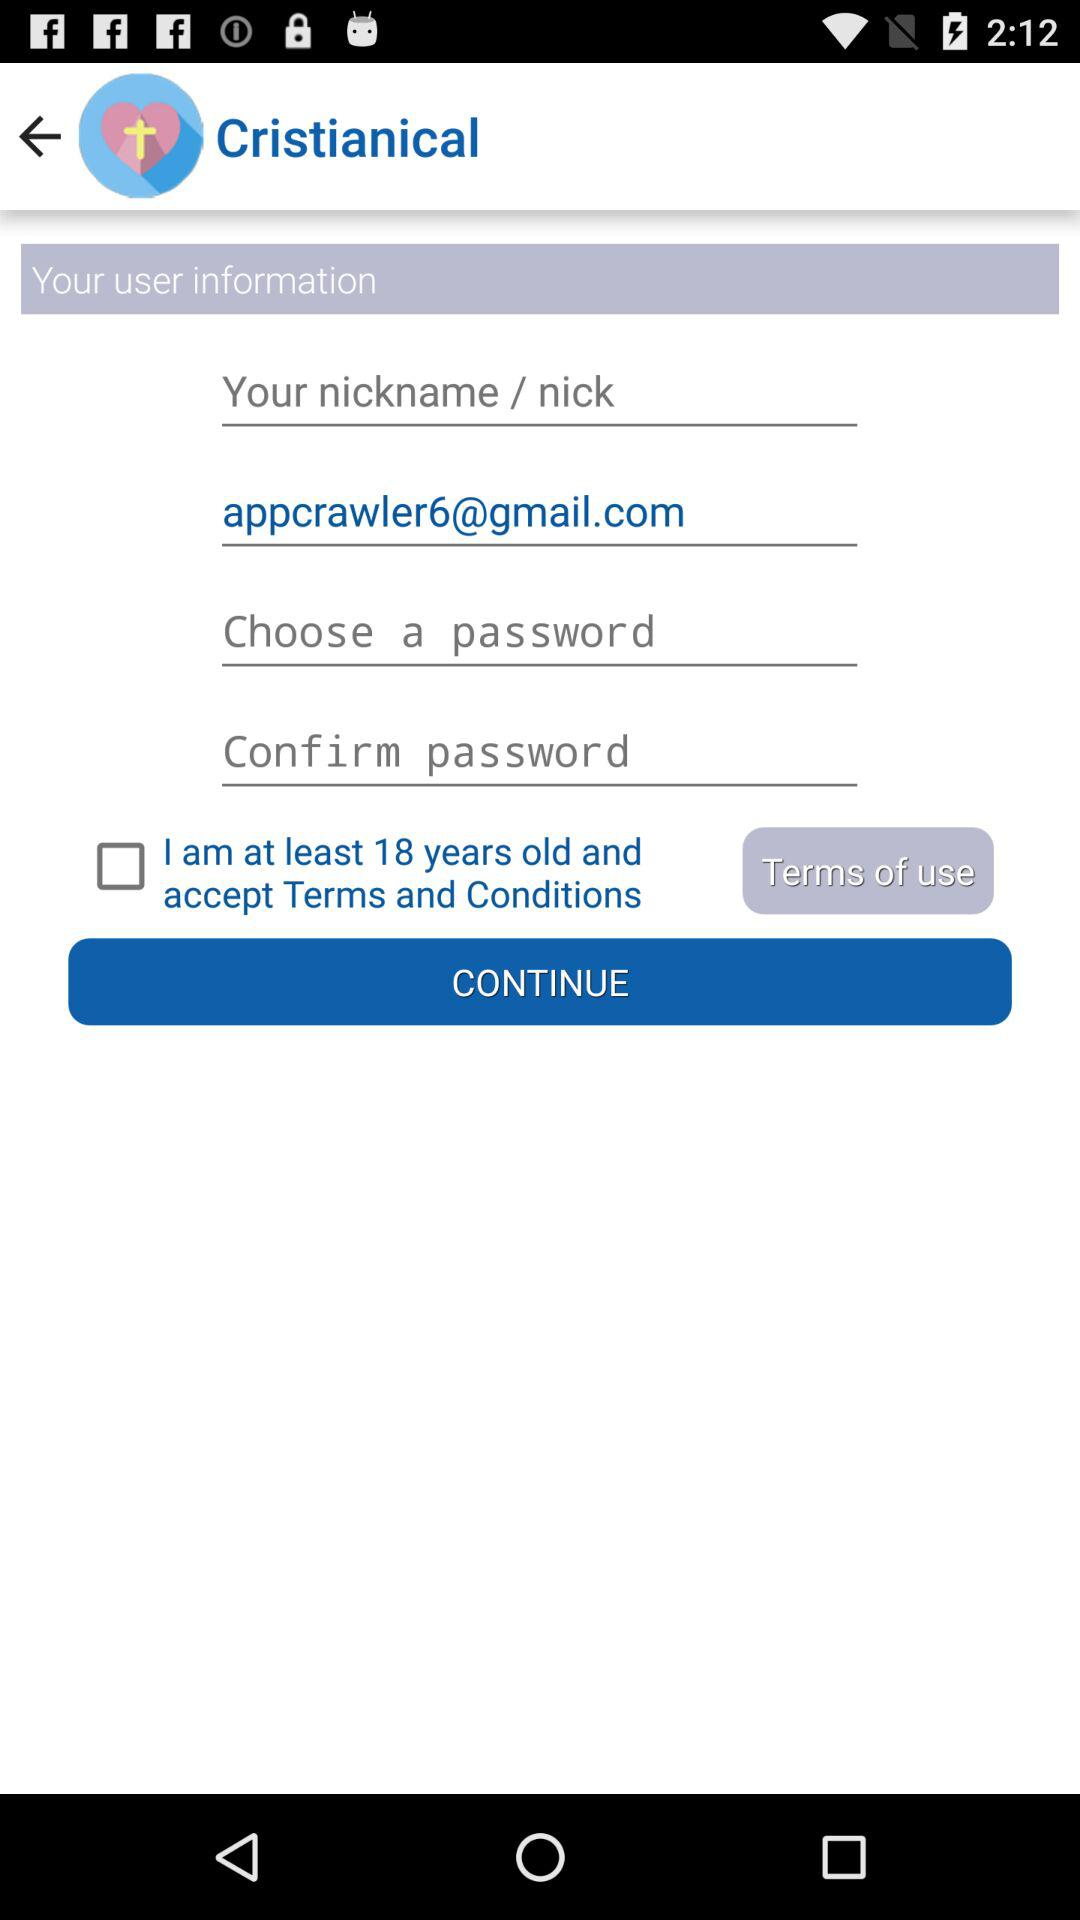What is the user's nickname?
When the provided information is insufficient, respond with <no answer>. <no answer> 